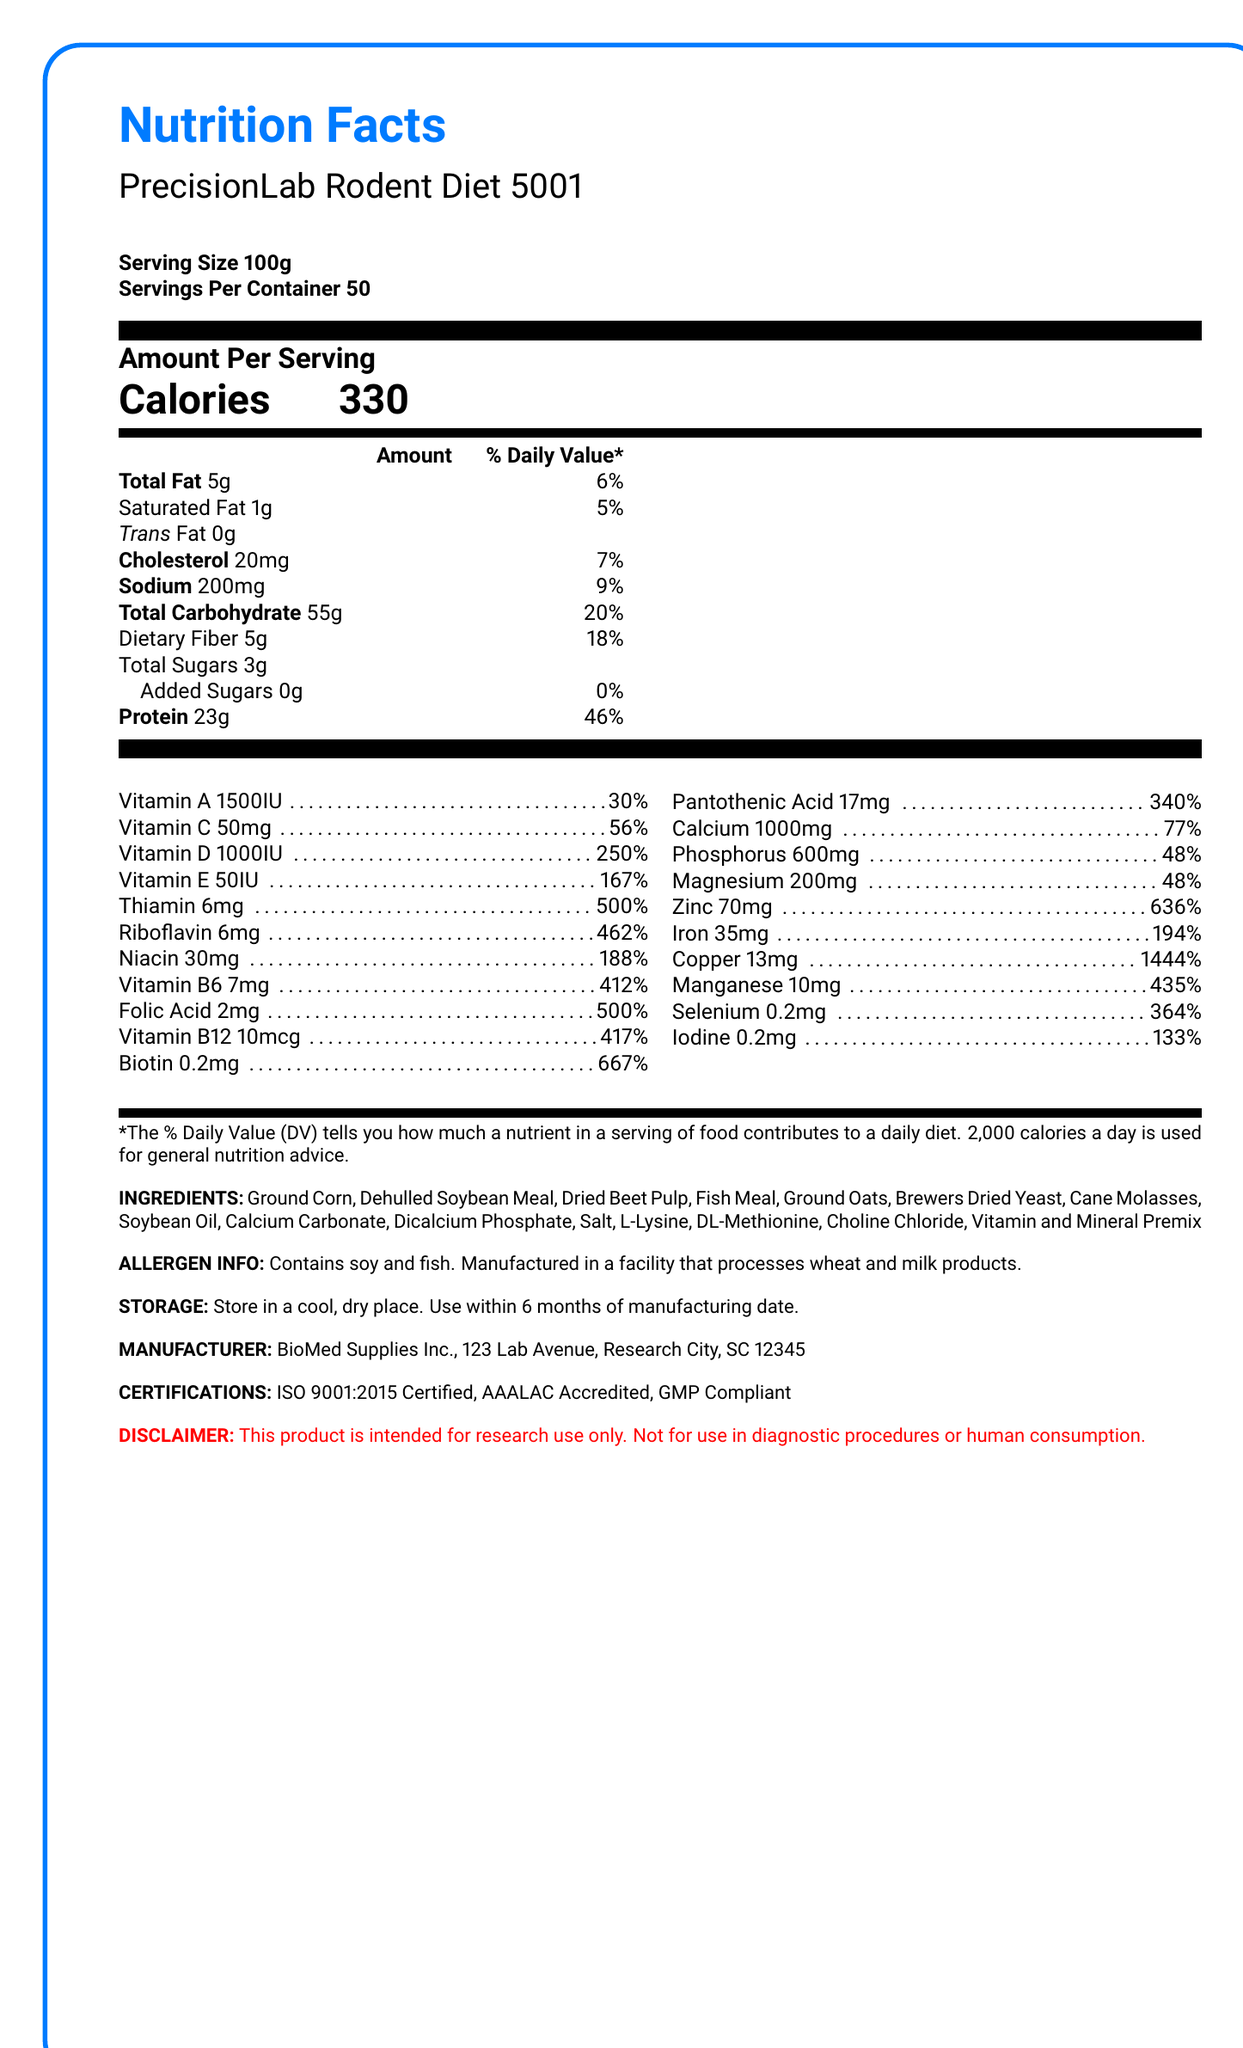what is the serving size for PrecisionLab Rodent Diet 5001? The serving size is explicitly listed as "Serving Size 100g" in the document.
Answer: 100g how many servings are there per container? The document states, "Servings Per Container 50."
Answer: 50 how many calories are in each serving? It is directly mentioned under the section "Amount Per Serving" as "Calories 330."
Answer: 330 what is the total fat content per serving and its daily value percentage? Under the macronutrients section, it is specifically listed as "Total Fat 5g" with a "6%" daily value.
Answer: 5g, 6% what ingredients are included in this rodent diet? All the ingredients are listed under the section "INGREDIENTS."
Answer: Ground Corn, Dehulled Soybean Meal, Dried Beet Pulp, Fish Meal, Ground Oats, Brewers Dried Yeast, Cane Molasses, Soybean Oil, Calcium Carbonate, Dicalcium Phosphate, Salt, L-Lysine, DL-Methionine, Choline Chloride, Vitamin and Mineral Premix what is the amount of iron per serving and its daily value percentage? In the micronutrients section, it states "Iron 35mg" with a "194%" daily value.
Answer: 35mg, 194% which of the following certifications does the product have? A. ISO 9001:2015 B. AAALAC C. GMP D. All of the above The document lists "ISO 9001:2015 Certified, AAALAC Accredited, GMP Compliant" under certifications.
Answer: D how much protein is in each serving? A. 10g B. 23g C. 30g D. 46g The document shows "Protein 23g" under the macronutrients section.
Answer: B is there any added sugar in this rodent diet? The document indicates "Added Sugars 0g" with a daily value of "0%."
Answer: No is the PrecisionLab Rodent Diet 5001 suitable for human consumption? The disclaimer at the bottom of the document states "This product is intended for research use only. Not for use in diagnostic procedures or human consumption."
Answer: No summarize the key nutritional information of PrecisionLab Rodent Diet 5001. The document provides detailed nutritional information, including macro and micronutrient breakdown, certifications, allergen information, storage instructions, and disclaimers.
Answer: PrecisionLab Rodent Diet 5001 contains 330 calories per 100g serving. It has 5g of fat, 55g of carbohydrates, and 23g of protein per serving. It also includes various vitamins and minerals such as Vitamin A, D, E, B-complex vitamins, calcium, iron, and zinc. The product is ISO 9001:2015 certified, AAALAC accredited, and GMP compliant. It contains soy and fish and is intended for research use only, not for human consumption. where was the rodent diet manufactured? The document lists the manufacturer as "BioMed Supplies Inc., 123 Lab Avenue, Research City, SC 12345" under the manufacturer info section.
Answer: BioMed Supplies Inc., 123 Lab Avenue, Research City, SC 12345 what is the daily value percentage of calcium in each serving? The micronutrient section mentions "Calcium 1000mg" as "77%" of the daily value.
Answer: 77% what is the main source of carbohydrate in this diet? The document lists "Ground Corn, Dehulled Soybean Meal, Dried Beet Pulp, Ground Oats" among the ingredients, but does not specify which ingredient is the main source of carbohydrates.
Answer: Cannot be determined 